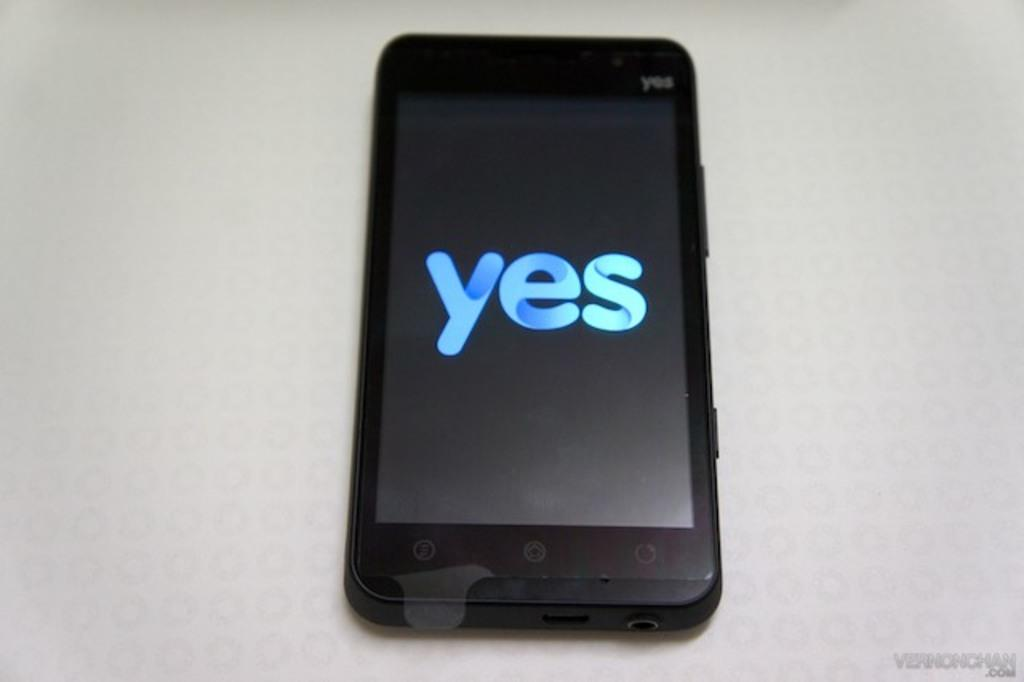<image>
Render a clear and concise summary of the photo. A cell phone with the word Yes in blue letters on the screen 